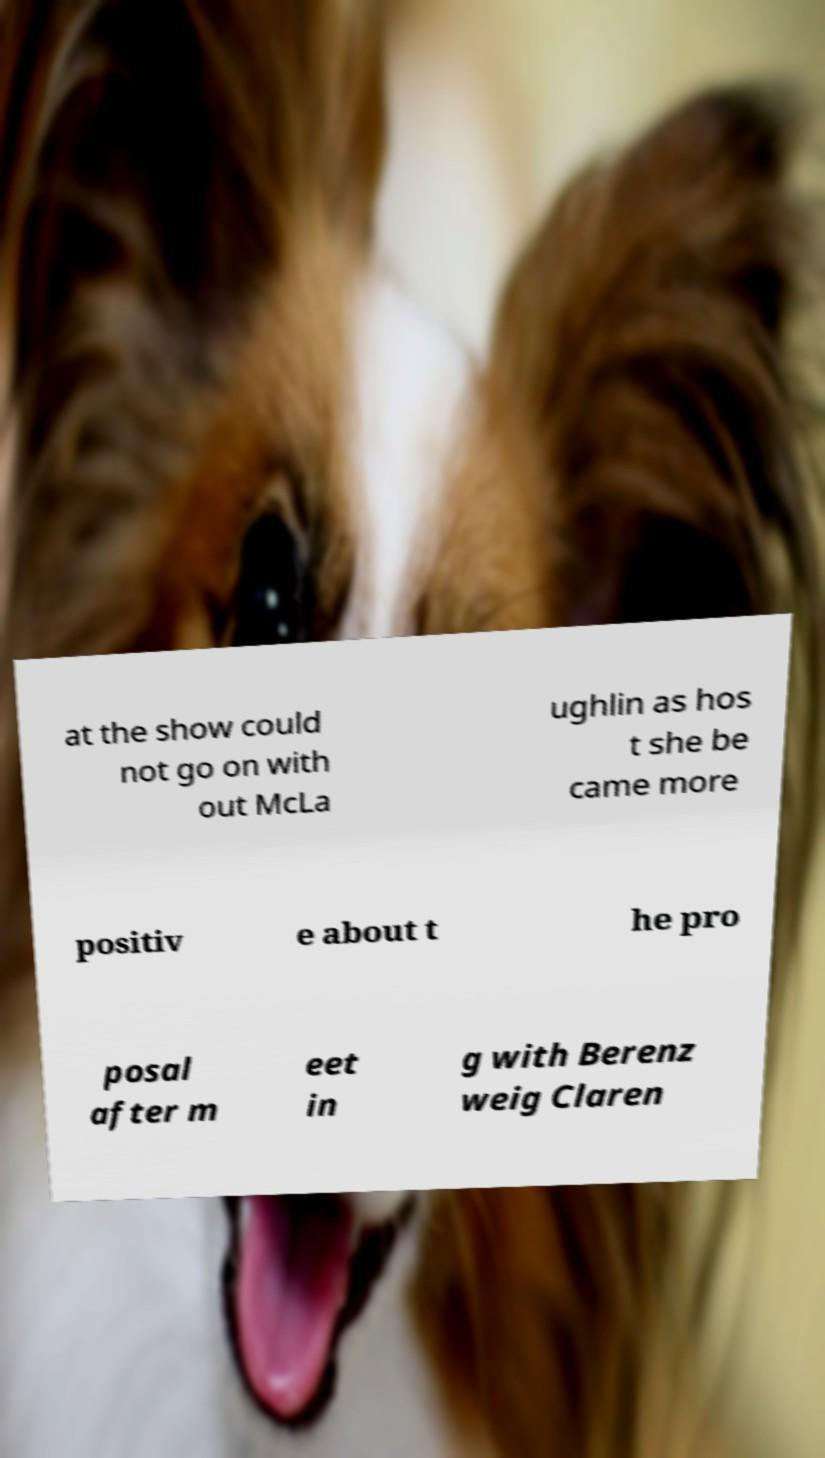Can you read and provide the text displayed in the image?This photo seems to have some interesting text. Can you extract and type it out for me? at the show could not go on with out McLa ughlin as hos t she be came more positiv e about t he pro posal after m eet in g with Berenz weig Claren 